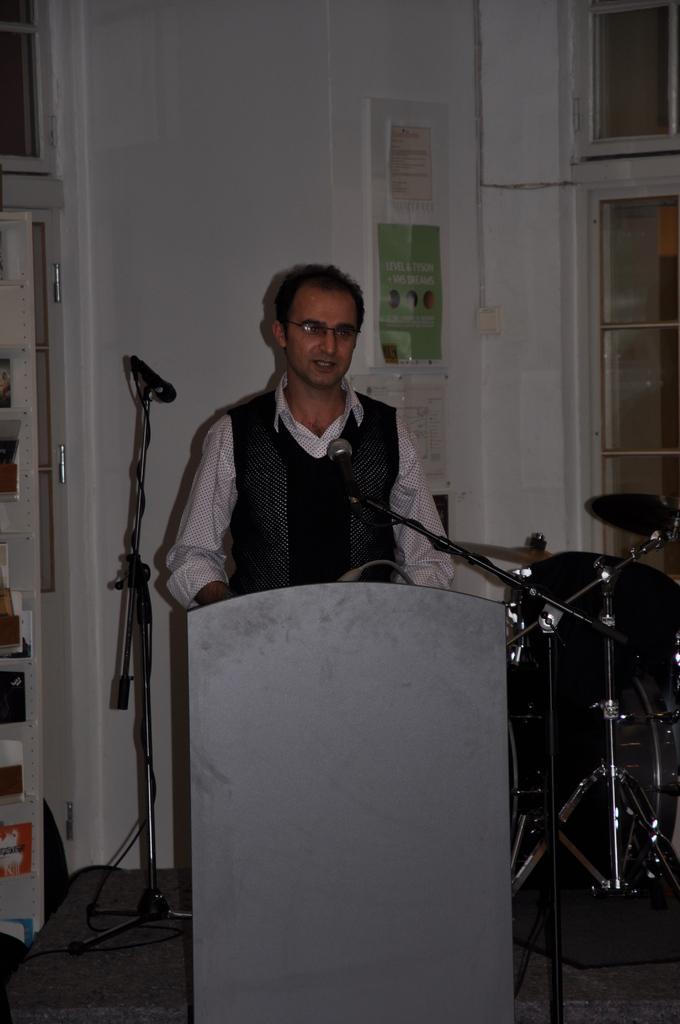Please provide a concise description of this image. In this picture I can see a man standing in front of a podium and I can see 2 mics near to him. On the right side of this picture, I can see a musical instrument. In the background I can see the wall and I can see the posters on it. On the left bottom of this picture I can see few wires. 